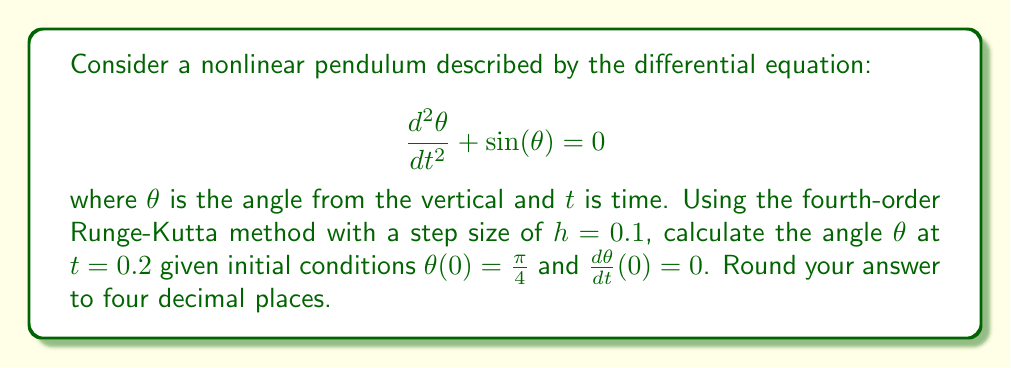What is the answer to this math problem? To solve this problem using the fourth-order Runge-Kutta method, we need to follow these steps:

1) First, we rewrite the second-order differential equation as a system of two first-order equations:

   Let $y_1 = \theta$ and $y_2 = \frac{d\theta}{dt}$

   Then, $\frac{dy_1}{dt} = y_2$ and $\frac{dy_2}{dt} = -\sin(y_1)$

2) The initial conditions are $y_1(0) = \frac{\pi}{4}$ and $y_2(0) = 0$

3) The fourth-order Runge-Kutta method for a system of equations is:

   $k_{1,i} = hf_i(t_n, y_{1,n}, y_{2,n})$
   $k_{2,i} = hf_i(t_n + \frac{h}{2}, y_{1,n} + \frac{k_{1,1}}{2}, y_{2,n} + \frac{k_{1,2}}{2})$
   $k_{3,i} = hf_i(t_n + \frac{h}{2}, y_{1,n} + \frac{k_{2,1}}{2}, y_{2,n} + \frac{k_{2,2}}{2})$
   $k_{4,i} = hf_i(t_n + h, y_{1,n} + k_{3,1}, y_{2,n} + k_{3,2})$

   $y_{i,n+1} = y_{i,n} + \frac{1}{6}(k_{1,i} + 2k_{2,i} + 2k_{3,i} + k_{4,i})$

   where $i = 1, 2$ for our system of two equations.

4) We need to calculate two steps to reach $t = 0.2$:

   Step 1 (from $t = 0$ to $t = 0.1$):
   
   $k_{1,1} = 0.1 \cdot 0 = 0$
   $k_{1,2} = 0.1 \cdot (-\sin(\frac{\pi}{4})) = -0.07071$
   
   $k_{2,1} = 0.1 \cdot (-0.03536) = -0.003536$
   $k_{2,2} = 0.1 \cdot (-\sin(0.7854)) = -0.07071$
   
   $k_{3,1} = 0.1 \cdot (-0.03536) = -0.003536$
   $k_{3,2} = 0.1 \cdot (-\sin(0.7854)) = -0.07071$
   
   $k_{4,1} = 0.1 \cdot (-0.07071) = -0.007071$
   $k_{4,2} = 0.1 \cdot (-\sin(0.7818)) = -0.07039$
   
   $y_{1,1} = 0.7854 + \frac{1}{6}(0 - 0.007072 - 0.007072 - 0.007071) = 0.7818$
   $y_{2,1} = 0 + \frac{1}{6}(-0.07071 - 0.14142 - 0.14142 - 0.07039) = -0.07063$

   Step 2 (from $t = 0.1$ to $t = 0.2$):
   
   $k_{1,1} = 0.1 \cdot (-0.07063) = -0.007063$
   $k_{1,2} = 0.1 \cdot (-\sin(0.7818)) = -0.07039$
   
   $k_{2,1} = 0.1 \cdot (-0.10582) = -0.010582$
   $k_{2,2} = 0.1 \cdot (-\sin(0.7783)) = -0.07007$
   
   $k_{3,1} = 0.1 \cdot (-0.10567) = -0.010567$
   $k_{3,2} = 0.1 \cdot (-\sin(0.7783)) = -0.07007$
   
   $k_{4,1} = 0.1 \cdot (-0.14070) = -0.014070$
   $k_{4,2} = 0.1 \cdot (-\sin(0.7712)) = -0.06943$
   
   $y_{1,2} = 0.7818 + \frac{1}{6}(-0.007063 - 0.021164 - 0.021134 - 0.014070) = 0.7712$
   $y_{2,2} = -0.07063 + \frac{1}{6}(-0.07039 - 0.14014 - 0.14014 - 0.06943) = -0.14070$

5) The final angle $\theta$ at $t = 0.2$ is $y_{1,2} = 0.7712$ radians.
Answer: 0.7712 